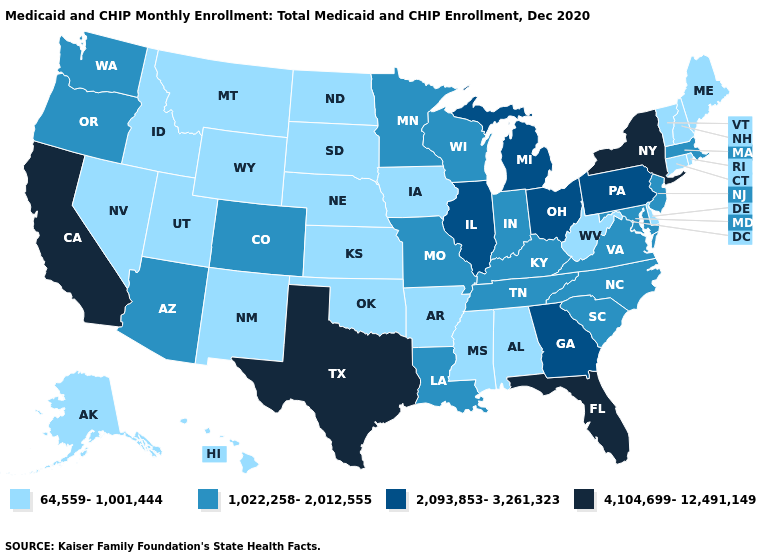How many symbols are there in the legend?
Give a very brief answer. 4. What is the highest value in states that border Virginia?
Answer briefly. 1,022,258-2,012,555. Does Alaska have the lowest value in the USA?
Give a very brief answer. Yes. Does New York have the highest value in the USA?
Answer briefly. Yes. Does Arizona have a lower value than New Mexico?
Keep it brief. No. Does Iowa have the lowest value in the USA?
Quick response, please. Yes. Is the legend a continuous bar?
Keep it brief. No. Among the states that border Montana , which have the lowest value?
Concise answer only. Idaho, North Dakota, South Dakota, Wyoming. What is the value of Nevada?
Keep it brief. 64,559-1,001,444. What is the value of Maryland?
Give a very brief answer. 1,022,258-2,012,555. Among the states that border Michigan , which have the lowest value?
Answer briefly. Indiana, Wisconsin. Is the legend a continuous bar?
Keep it brief. No. What is the value of Ohio?
Answer briefly. 2,093,853-3,261,323. Name the states that have a value in the range 1,022,258-2,012,555?
Short answer required. Arizona, Colorado, Indiana, Kentucky, Louisiana, Maryland, Massachusetts, Minnesota, Missouri, New Jersey, North Carolina, Oregon, South Carolina, Tennessee, Virginia, Washington, Wisconsin. Which states have the lowest value in the USA?
Answer briefly. Alabama, Alaska, Arkansas, Connecticut, Delaware, Hawaii, Idaho, Iowa, Kansas, Maine, Mississippi, Montana, Nebraska, Nevada, New Hampshire, New Mexico, North Dakota, Oklahoma, Rhode Island, South Dakota, Utah, Vermont, West Virginia, Wyoming. 